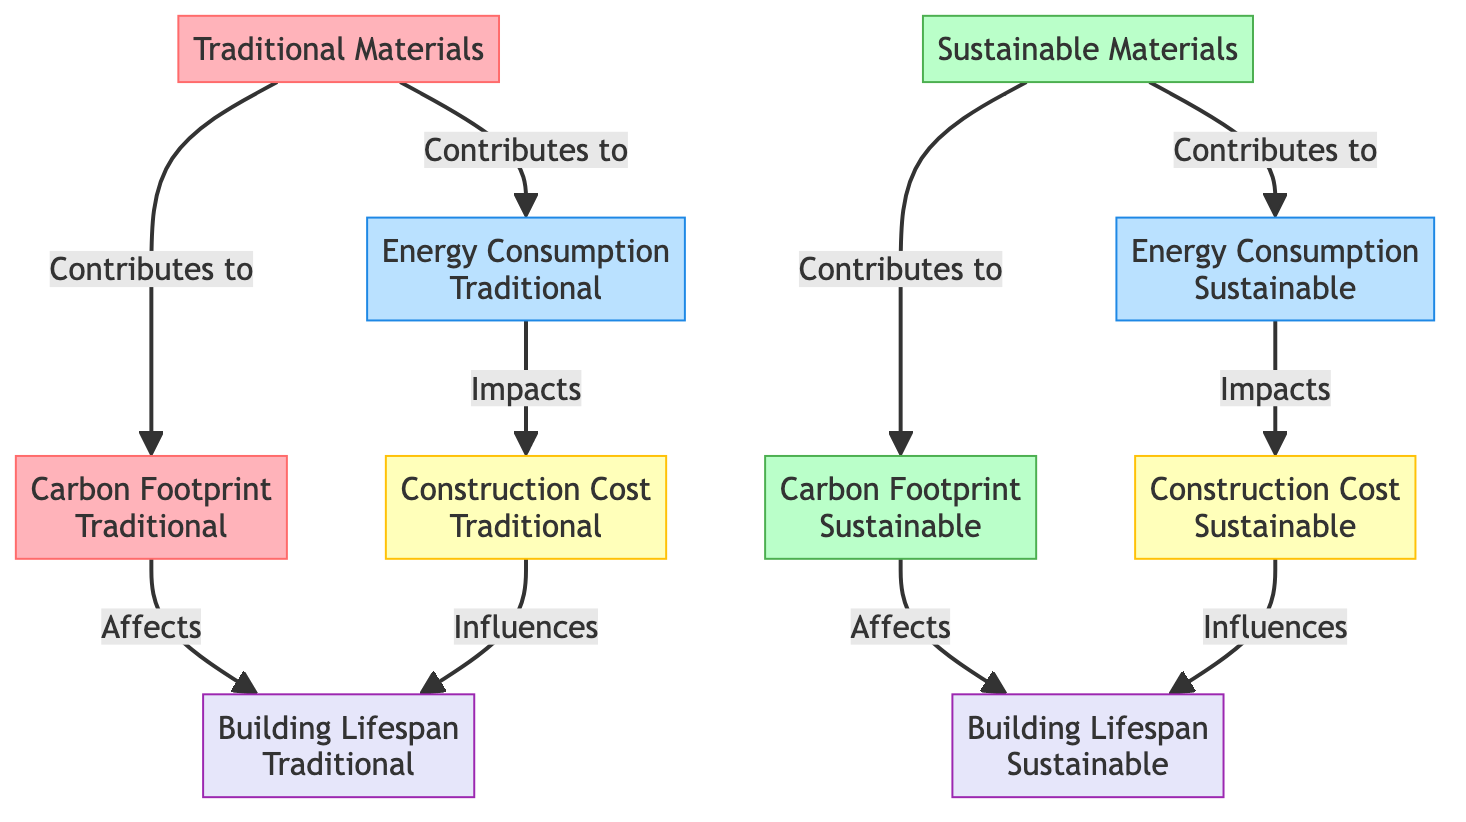What is the label of the node that represents the long-term energy usage impact of traditional construction practices? The diagram shows a node contributing to the energy consumption of traditional materials. This node is labeled "Energy Consumption (Traditional)," which reflects its relationship as a descriptor of long-term energy use.
Answer: Energy Consumption (Traditional) How many nodes are represented in the diagram? The diagram lists ten distinct nodes, each representing different aspects of traditional and sustainable construction practices, such as materials, energy consumption, carbon footprint, construction cost, and building lifespan.
Answer: 10 Which node directly impacts the construction cost associated with sustainable materials? By tracing the edges from the "Energy Consumption (Sustainable)" node, we can see that there is a direct edge labeled "Impacts," leading to the node "Construction Cost (Sustainable)." This indicates the link between energy consumption and cost.
Answer: Construction Cost (Sustainable) What type of materials contribute to a lower carbon footprint? In the diagram, it is indicated that the node "Sustainable Materials" contributes to "Carbon Footprint (Sustainable)," showcasing the role of these eco-friendly materials in reducing carbon emissions.
Answer: Sustainable Materials Which factor affects the building lifespan of traditional construction practices? The relationship in the diagram shows that "Carbon Footprint (Traditional)" has a direct connection labeled "Affects" to "Building Lifespan (Traditional)," indicating that higher emissions may impact the durability of such buildings.
Answer: Carbon Footprint (Traditional) How are traditional materials related to carbon footprint? The diagram depicts that traditional materials contribute to the carbon footprint through direct edges from the "Traditional Materials" node to the "Carbon Footprint (Traditional)" node, establishing a clear relationship.
Answer: Contributes to What distinguishes the long-term cost implication of sustainable construction compared to traditional methods? The diagram illustrates that "Construction Cost (Sustainable)" is influenced by lower energy usage through a direct link from "Energy Consumption (Sustainable)," while traditional methods show generally lower initial costs but higher long-term costs, delineating differences.
Answer: Higher initial investment Which node signifies the energy consumption of sustainable practices? The "Energy Consumption (Sustainable)" node exists in the diagram, linked to sustainable materials, indicating its role in the context of sustainable construction practices.
Answer: Energy Consumption (Sustainable) Which nodes connect to the building lifespan concerning traditional construction costs? The diagram indicates two nodes affect "Building Lifespan (Traditional)"; they are the "Carbon Footprint (Traditional)" and "Construction Cost (Traditional)," both influencing traditional practices' durability.
Answer: Carbon Footprint (Traditional), Construction Cost (Traditional) 